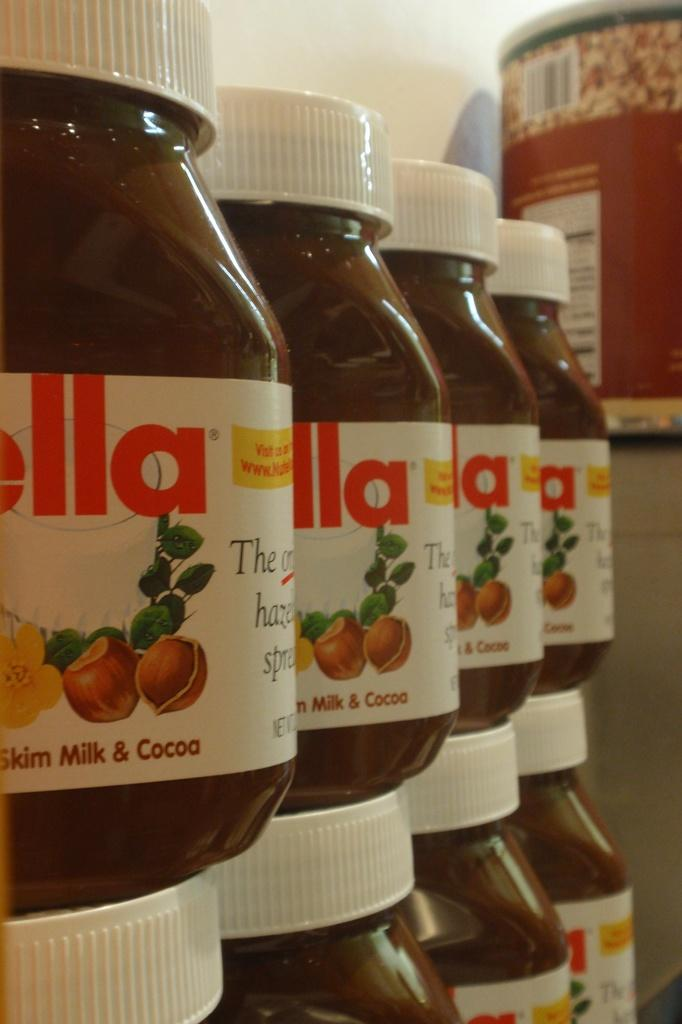What type of product is featured in the image? There are bottles of Nutella in the image. How many dogs are attempting to use a fork to open the Nutella bottles in the image? There are no dogs or forks present in the image. 